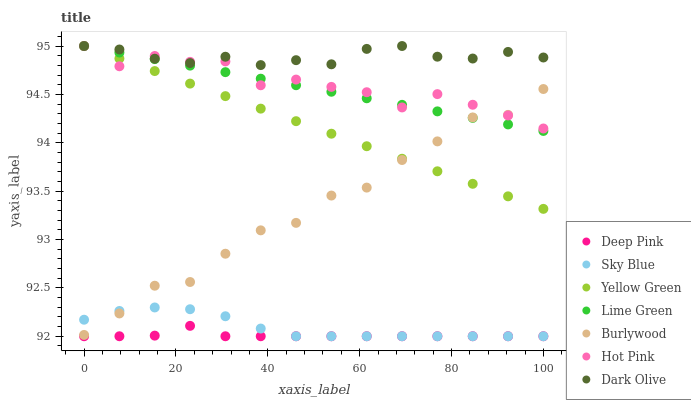Does Deep Pink have the minimum area under the curve?
Answer yes or no. Yes. Does Dark Olive have the maximum area under the curve?
Answer yes or no. Yes. Does Yellow Green have the minimum area under the curve?
Answer yes or no. No. Does Yellow Green have the maximum area under the curve?
Answer yes or no. No. Is Yellow Green the smoothest?
Answer yes or no. Yes. Is Burlywood the roughest?
Answer yes or no. Yes. Is Burlywood the smoothest?
Answer yes or no. No. Is Yellow Green the roughest?
Answer yes or no. No. Does Deep Pink have the lowest value?
Answer yes or no. Yes. Does Yellow Green have the lowest value?
Answer yes or no. No. Does Lime Green have the highest value?
Answer yes or no. Yes. Does Burlywood have the highest value?
Answer yes or no. No. Is Sky Blue less than Hot Pink?
Answer yes or no. Yes. Is Lime Green greater than Deep Pink?
Answer yes or no. Yes. Does Lime Green intersect Hot Pink?
Answer yes or no. Yes. Is Lime Green less than Hot Pink?
Answer yes or no. No. Is Lime Green greater than Hot Pink?
Answer yes or no. No. Does Sky Blue intersect Hot Pink?
Answer yes or no. No. 